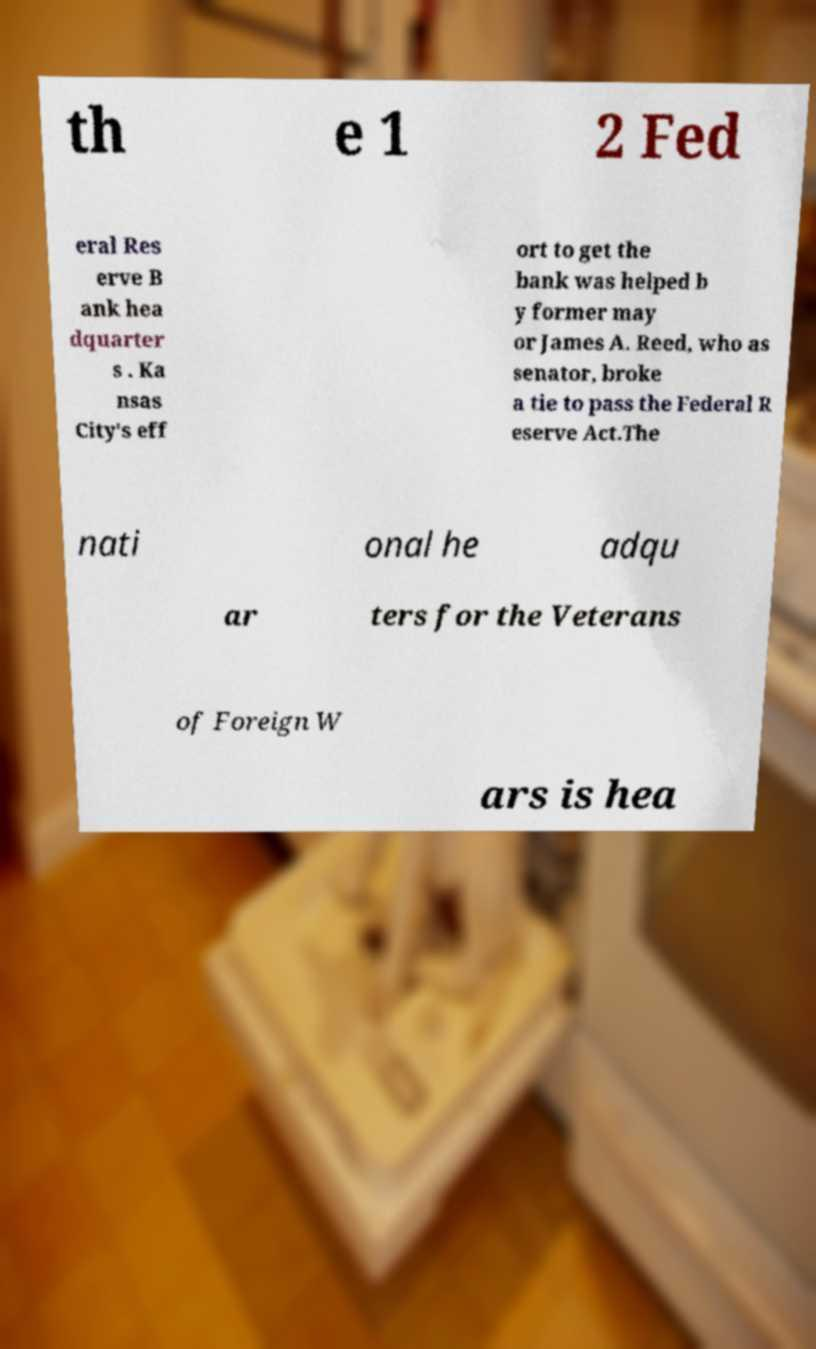Can you read and provide the text displayed in the image?This photo seems to have some interesting text. Can you extract and type it out for me? th e 1 2 Fed eral Res erve B ank hea dquarter s . Ka nsas City's eff ort to get the bank was helped b y former may or James A. Reed, who as senator, broke a tie to pass the Federal R eserve Act.The nati onal he adqu ar ters for the Veterans of Foreign W ars is hea 